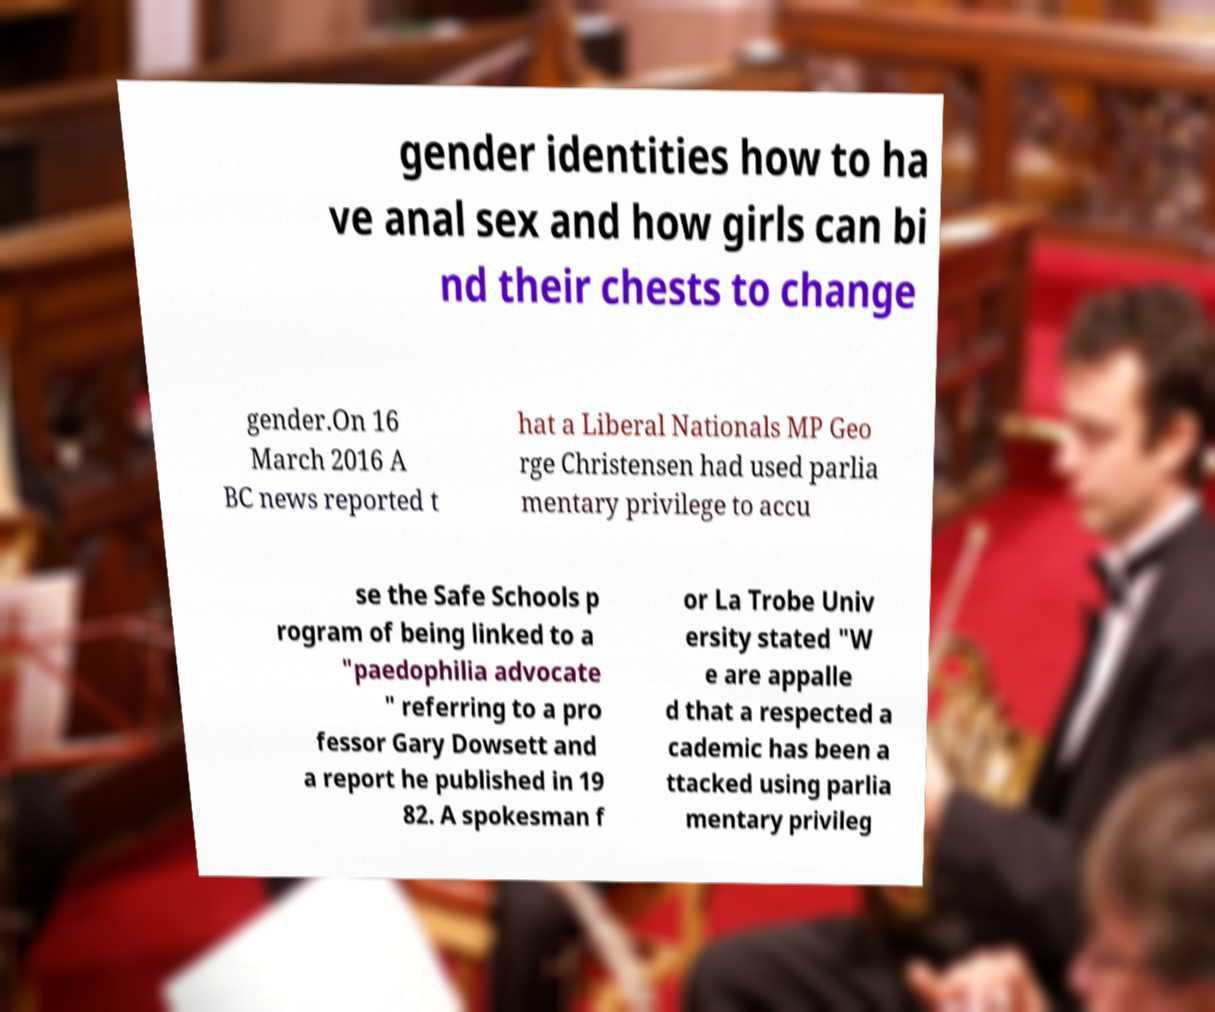Can you read and provide the text displayed in the image?This photo seems to have some interesting text. Can you extract and type it out for me? gender identities how to ha ve anal sex and how girls can bi nd their chests to change gender.On 16 March 2016 A BC news reported t hat a Liberal Nationals MP Geo rge Christensen had used parlia mentary privilege to accu se the Safe Schools p rogram of being linked to a "paedophilia advocate " referring to a pro fessor Gary Dowsett and a report he published in 19 82. A spokesman f or La Trobe Univ ersity stated "W e are appalle d that a respected a cademic has been a ttacked using parlia mentary privileg 